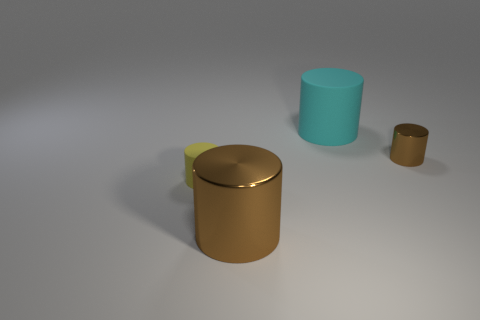Subtract 1 cylinders. How many cylinders are left? 3 Subtract all cyan cylinders. How many cylinders are left? 3 Subtract all small brown metallic cylinders. How many cylinders are left? 3 Subtract all green cylinders. Subtract all green blocks. How many cylinders are left? 4 Add 4 red shiny spheres. How many objects exist? 8 Subtract all cylinders. Subtract all purple shiny cylinders. How many objects are left? 0 Add 3 tiny yellow objects. How many tiny yellow objects are left? 4 Add 3 big red cylinders. How many big red cylinders exist? 3 Subtract 0 gray spheres. How many objects are left? 4 